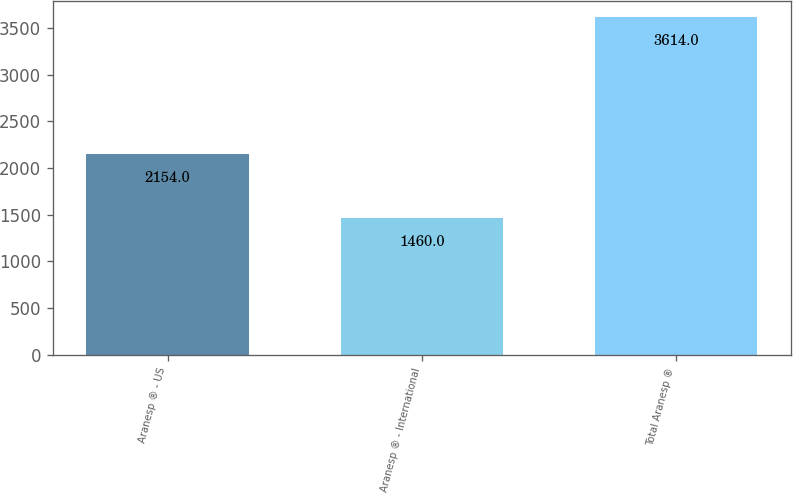Convert chart to OTSL. <chart><loc_0><loc_0><loc_500><loc_500><bar_chart><fcel>Aranesp ® - US<fcel>Aranesp ® - International<fcel>Total Aranesp ®<nl><fcel>2154<fcel>1460<fcel>3614<nl></chart> 